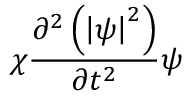Convert formula to latex. <formula><loc_0><loc_0><loc_500><loc_500>\chi \frac { \partial ^ { 2 } \left ( \left | \psi \right | ^ { 2 } \right ) } { \partial t ^ { 2 } } \psi</formula> 